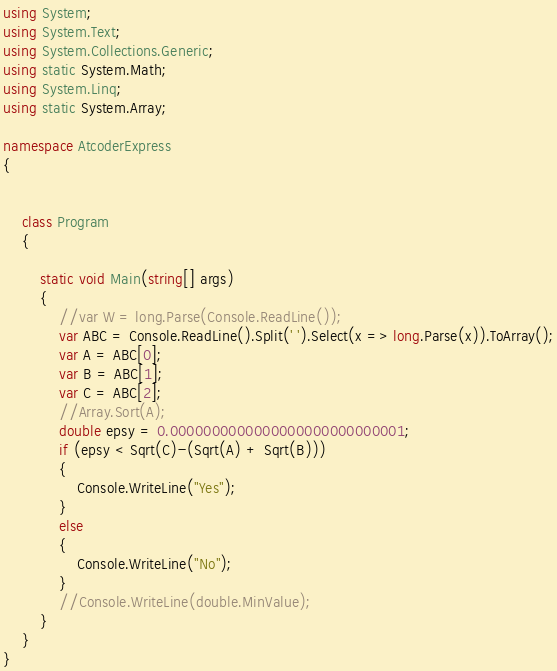Convert code to text. <code><loc_0><loc_0><loc_500><loc_500><_C#_>using System;
using System.Text;
using System.Collections.Generic;
using static System.Math;
using System.Linq;
using static System.Array;

namespace AtcoderExpress
{


    class Program
    {

        static void Main(string[] args)
        {
            //var W = long.Parse(Console.ReadLine());
            var ABC = Console.ReadLine().Split(' ').Select(x => long.Parse(x)).ToArray();
            var A = ABC[0];
            var B = ABC[1];
            var C = ABC[2];
            //Array.Sort(A);
            double epsy = 0.0000000000000000000000000001;
            if (epsy < Sqrt(C)-(Sqrt(A) + Sqrt(B)))
            {
                Console.WriteLine("Yes");
            }
            else
            {
                Console.WriteLine("No");
            }
            //Console.WriteLine(double.MinValue);
        }
    }
}
</code> 